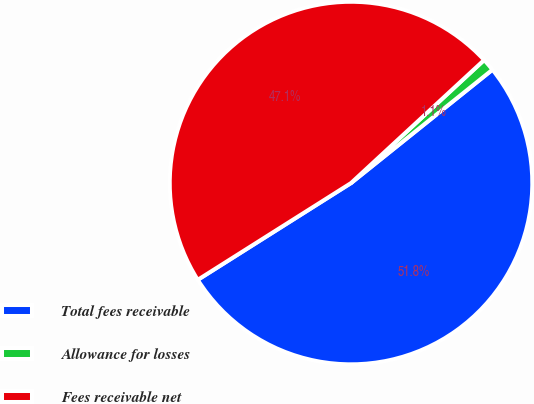Convert chart. <chart><loc_0><loc_0><loc_500><loc_500><pie_chart><fcel>Total fees receivable<fcel>Allowance for losses<fcel>Fees receivable net<nl><fcel>51.79%<fcel>1.12%<fcel>47.09%<nl></chart> 